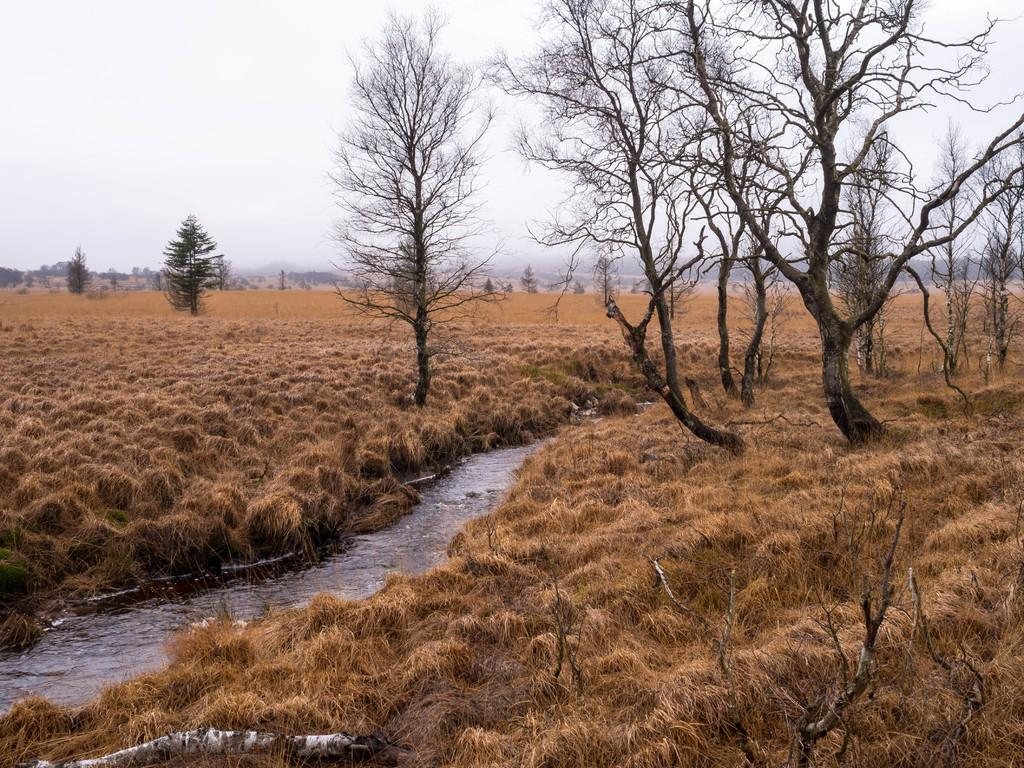What is one of the main elements in the image? There is water in the image. What type of vegetation can be seen in the image? There is dried grass and trees in the image. What can be seen in the background of the image? The sky is visible in the background of the image. How many chickens are visible in the image? There are no chickens present in the image. Can you describe the bee's activity in the image? There are no bees present in the image. 